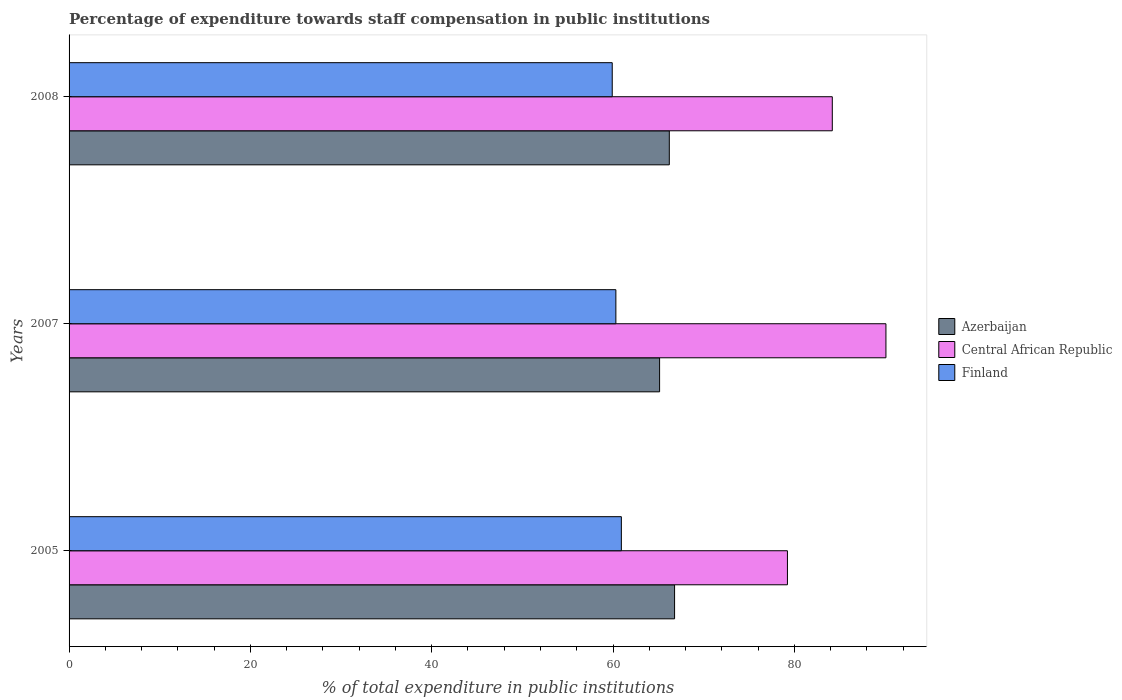How many different coloured bars are there?
Give a very brief answer. 3. Are the number of bars on each tick of the Y-axis equal?
Offer a terse response. Yes. How many bars are there on the 1st tick from the top?
Offer a terse response. 3. How many bars are there on the 1st tick from the bottom?
Ensure brevity in your answer.  3. In how many cases, is the number of bars for a given year not equal to the number of legend labels?
Make the answer very short. 0. What is the percentage of expenditure towards staff compensation in Central African Republic in 2007?
Provide a succinct answer. 90.11. Across all years, what is the maximum percentage of expenditure towards staff compensation in Azerbaijan?
Provide a short and direct response. 66.79. Across all years, what is the minimum percentage of expenditure towards staff compensation in Azerbaijan?
Give a very brief answer. 65.14. In which year was the percentage of expenditure towards staff compensation in Finland minimum?
Provide a short and direct response. 2008. What is the total percentage of expenditure towards staff compensation in Azerbaijan in the graph?
Provide a short and direct response. 198.14. What is the difference between the percentage of expenditure towards staff compensation in Azerbaijan in 2005 and that in 2007?
Keep it short and to the point. 1.65. What is the difference between the percentage of expenditure towards staff compensation in Finland in 2005 and the percentage of expenditure towards staff compensation in Azerbaijan in 2008?
Your answer should be compact. -5.29. What is the average percentage of expenditure towards staff compensation in Azerbaijan per year?
Provide a short and direct response. 66.05. In the year 2008, what is the difference between the percentage of expenditure towards staff compensation in Finland and percentage of expenditure towards staff compensation in Central African Republic?
Your answer should be compact. -24.28. In how many years, is the percentage of expenditure towards staff compensation in Central African Republic greater than 32 %?
Keep it short and to the point. 3. What is the ratio of the percentage of expenditure towards staff compensation in Azerbaijan in 2005 to that in 2008?
Provide a short and direct response. 1.01. What is the difference between the highest and the second highest percentage of expenditure towards staff compensation in Azerbaijan?
Make the answer very short. 0.58. What is the difference between the highest and the lowest percentage of expenditure towards staff compensation in Azerbaijan?
Your answer should be very brief. 1.65. In how many years, is the percentage of expenditure towards staff compensation in Central African Republic greater than the average percentage of expenditure towards staff compensation in Central African Republic taken over all years?
Your response must be concise. 1. What does the 1st bar from the top in 2007 represents?
Offer a very short reply. Finland. What does the 2nd bar from the bottom in 2005 represents?
Your response must be concise. Central African Republic. How many years are there in the graph?
Ensure brevity in your answer.  3. What is the difference between two consecutive major ticks on the X-axis?
Ensure brevity in your answer.  20. Are the values on the major ticks of X-axis written in scientific E-notation?
Provide a succinct answer. No. Does the graph contain any zero values?
Your answer should be very brief. No. Does the graph contain grids?
Keep it short and to the point. No. How are the legend labels stacked?
Keep it short and to the point. Vertical. What is the title of the graph?
Your answer should be compact. Percentage of expenditure towards staff compensation in public institutions. Does "Netherlands" appear as one of the legend labels in the graph?
Offer a terse response. No. What is the label or title of the X-axis?
Make the answer very short. % of total expenditure in public institutions. What is the label or title of the Y-axis?
Give a very brief answer. Years. What is the % of total expenditure in public institutions in Azerbaijan in 2005?
Offer a very short reply. 66.79. What is the % of total expenditure in public institutions of Central African Republic in 2005?
Ensure brevity in your answer.  79.24. What is the % of total expenditure in public institutions in Finland in 2005?
Your answer should be very brief. 60.92. What is the % of total expenditure in public institutions in Azerbaijan in 2007?
Provide a succinct answer. 65.14. What is the % of total expenditure in public institutions in Central African Republic in 2007?
Keep it short and to the point. 90.11. What is the % of total expenditure in public institutions in Finland in 2007?
Provide a succinct answer. 60.32. What is the % of total expenditure in public institutions of Azerbaijan in 2008?
Provide a succinct answer. 66.21. What is the % of total expenditure in public institutions in Central African Republic in 2008?
Your response must be concise. 84.19. What is the % of total expenditure in public institutions of Finland in 2008?
Offer a terse response. 59.91. Across all years, what is the maximum % of total expenditure in public institutions of Azerbaijan?
Provide a succinct answer. 66.79. Across all years, what is the maximum % of total expenditure in public institutions of Central African Republic?
Your response must be concise. 90.11. Across all years, what is the maximum % of total expenditure in public institutions of Finland?
Your answer should be very brief. 60.92. Across all years, what is the minimum % of total expenditure in public institutions of Azerbaijan?
Keep it short and to the point. 65.14. Across all years, what is the minimum % of total expenditure in public institutions in Central African Republic?
Your answer should be compact. 79.24. Across all years, what is the minimum % of total expenditure in public institutions in Finland?
Provide a succinct answer. 59.91. What is the total % of total expenditure in public institutions in Azerbaijan in the graph?
Provide a succinct answer. 198.14. What is the total % of total expenditure in public institutions of Central African Republic in the graph?
Your answer should be compact. 253.54. What is the total % of total expenditure in public institutions of Finland in the graph?
Your response must be concise. 181.15. What is the difference between the % of total expenditure in public institutions of Azerbaijan in 2005 and that in 2007?
Your response must be concise. 1.65. What is the difference between the % of total expenditure in public institutions in Central African Republic in 2005 and that in 2007?
Provide a succinct answer. -10.86. What is the difference between the % of total expenditure in public institutions in Finland in 2005 and that in 2007?
Provide a succinct answer. 0.6. What is the difference between the % of total expenditure in public institutions in Azerbaijan in 2005 and that in 2008?
Offer a terse response. 0.58. What is the difference between the % of total expenditure in public institutions of Central African Republic in 2005 and that in 2008?
Ensure brevity in your answer.  -4.95. What is the difference between the % of total expenditure in public institutions in Finland in 2005 and that in 2008?
Provide a short and direct response. 1.01. What is the difference between the % of total expenditure in public institutions of Azerbaijan in 2007 and that in 2008?
Your answer should be very brief. -1.07. What is the difference between the % of total expenditure in public institutions of Central African Republic in 2007 and that in 2008?
Provide a succinct answer. 5.92. What is the difference between the % of total expenditure in public institutions in Finland in 2007 and that in 2008?
Your answer should be very brief. 0.4. What is the difference between the % of total expenditure in public institutions of Azerbaijan in 2005 and the % of total expenditure in public institutions of Central African Republic in 2007?
Make the answer very short. -23.31. What is the difference between the % of total expenditure in public institutions of Azerbaijan in 2005 and the % of total expenditure in public institutions of Finland in 2007?
Your answer should be very brief. 6.47. What is the difference between the % of total expenditure in public institutions in Central African Republic in 2005 and the % of total expenditure in public institutions in Finland in 2007?
Offer a terse response. 18.92. What is the difference between the % of total expenditure in public institutions of Azerbaijan in 2005 and the % of total expenditure in public institutions of Central African Republic in 2008?
Give a very brief answer. -17.4. What is the difference between the % of total expenditure in public institutions in Azerbaijan in 2005 and the % of total expenditure in public institutions in Finland in 2008?
Offer a very short reply. 6.88. What is the difference between the % of total expenditure in public institutions of Central African Republic in 2005 and the % of total expenditure in public institutions of Finland in 2008?
Offer a very short reply. 19.33. What is the difference between the % of total expenditure in public institutions of Azerbaijan in 2007 and the % of total expenditure in public institutions of Central African Republic in 2008?
Your response must be concise. -19.05. What is the difference between the % of total expenditure in public institutions of Azerbaijan in 2007 and the % of total expenditure in public institutions of Finland in 2008?
Make the answer very short. 5.22. What is the difference between the % of total expenditure in public institutions of Central African Republic in 2007 and the % of total expenditure in public institutions of Finland in 2008?
Make the answer very short. 30.19. What is the average % of total expenditure in public institutions of Azerbaijan per year?
Offer a terse response. 66.05. What is the average % of total expenditure in public institutions in Central African Republic per year?
Make the answer very short. 84.51. What is the average % of total expenditure in public institutions of Finland per year?
Offer a terse response. 60.38. In the year 2005, what is the difference between the % of total expenditure in public institutions in Azerbaijan and % of total expenditure in public institutions in Central African Republic?
Offer a terse response. -12.45. In the year 2005, what is the difference between the % of total expenditure in public institutions in Azerbaijan and % of total expenditure in public institutions in Finland?
Make the answer very short. 5.87. In the year 2005, what is the difference between the % of total expenditure in public institutions of Central African Republic and % of total expenditure in public institutions of Finland?
Your answer should be compact. 18.32. In the year 2007, what is the difference between the % of total expenditure in public institutions of Azerbaijan and % of total expenditure in public institutions of Central African Republic?
Give a very brief answer. -24.97. In the year 2007, what is the difference between the % of total expenditure in public institutions of Azerbaijan and % of total expenditure in public institutions of Finland?
Keep it short and to the point. 4.82. In the year 2007, what is the difference between the % of total expenditure in public institutions of Central African Republic and % of total expenditure in public institutions of Finland?
Give a very brief answer. 29.79. In the year 2008, what is the difference between the % of total expenditure in public institutions of Azerbaijan and % of total expenditure in public institutions of Central African Republic?
Your answer should be compact. -17.98. In the year 2008, what is the difference between the % of total expenditure in public institutions in Azerbaijan and % of total expenditure in public institutions in Finland?
Make the answer very short. 6.3. In the year 2008, what is the difference between the % of total expenditure in public institutions of Central African Republic and % of total expenditure in public institutions of Finland?
Your answer should be compact. 24.28. What is the ratio of the % of total expenditure in public institutions of Azerbaijan in 2005 to that in 2007?
Keep it short and to the point. 1.03. What is the ratio of the % of total expenditure in public institutions in Central African Republic in 2005 to that in 2007?
Offer a terse response. 0.88. What is the ratio of the % of total expenditure in public institutions of Finland in 2005 to that in 2007?
Ensure brevity in your answer.  1.01. What is the ratio of the % of total expenditure in public institutions of Azerbaijan in 2005 to that in 2008?
Offer a terse response. 1.01. What is the ratio of the % of total expenditure in public institutions of Finland in 2005 to that in 2008?
Give a very brief answer. 1.02. What is the ratio of the % of total expenditure in public institutions in Azerbaijan in 2007 to that in 2008?
Your answer should be very brief. 0.98. What is the ratio of the % of total expenditure in public institutions of Central African Republic in 2007 to that in 2008?
Provide a succinct answer. 1.07. What is the difference between the highest and the second highest % of total expenditure in public institutions in Azerbaijan?
Make the answer very short. 0.58. What is the difference between the highest and the second highest % of total expenditure in public institutions of Central African Republic?
Your response must be concise. 5.92. What is the difference between the highest and the second highest % of total expenditure in public institutions of Finland?
Give a very brief answer. 0.6. What is the difference between the highest and the lowest % of total expenditure in public institutions of Azerbaijan?
Offer a terse response. 1.65. What is the difference between the highest and the lowest % of total expenditure in public institutions of Central African Republic?
Provide a short and direct response. 10.86. What is the difference between the highest and the lowest % of total expenditure in public institutions of Finland?
Give a very brief answer. 1.01. 